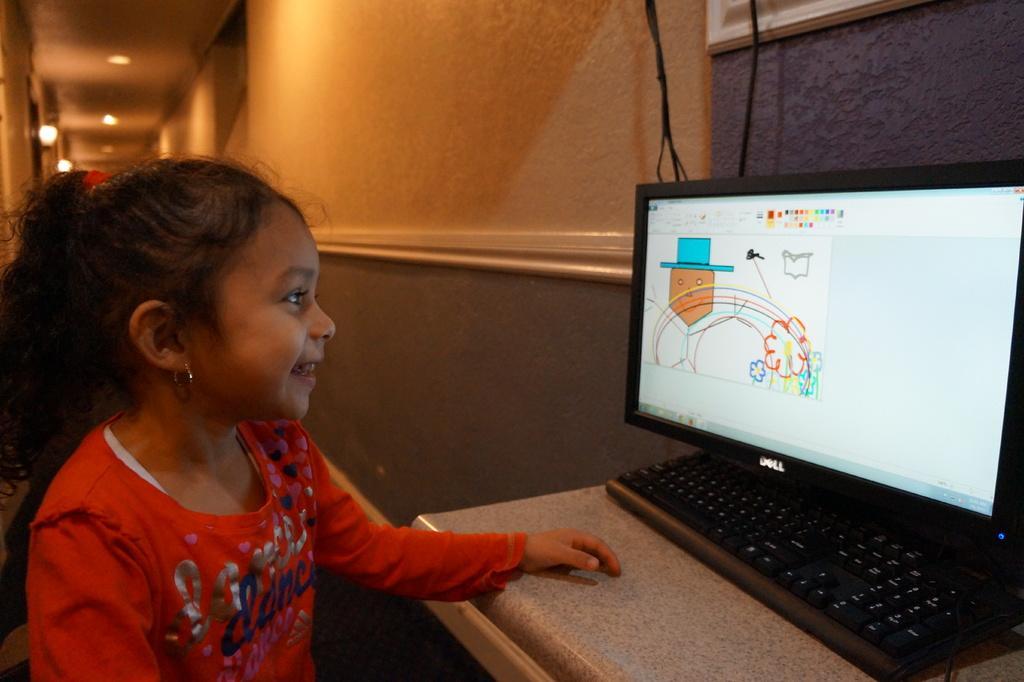Describe this image in one or two sentences. This is the girl sitting and smiling. She wore a red color T-shirt. This is the table with a keyboard and monitor. Here is the wall. These are the wires hanging. In the background, I can see the lamps attached to the wall. 